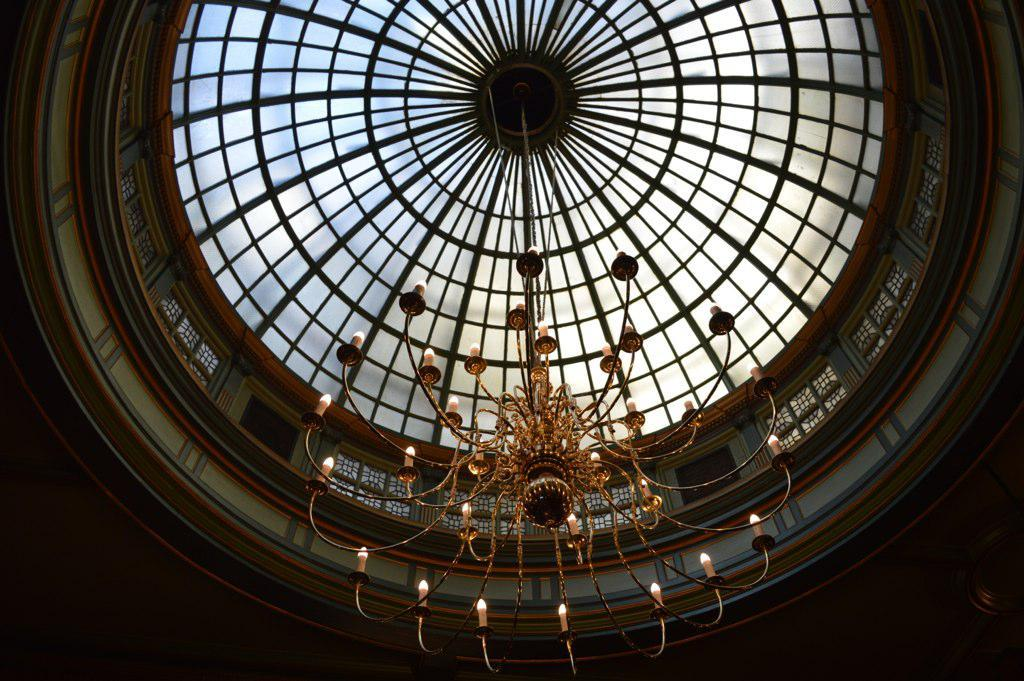What type of lighting fixture is present in the image? There is a chandelier in the image. What part of the building can be seen in the image? The roof is visible in the image. How would you describe the lighting conditions in the image? The environment in the image appears to be dark. How many fingers can be seen holding the apple in the image? There is no apple or fingers present in the image. 